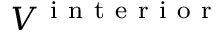<formula> <loc_0><loc_0><loc_500><loc_500>V ^ { i n t e r i o r }</formula> 